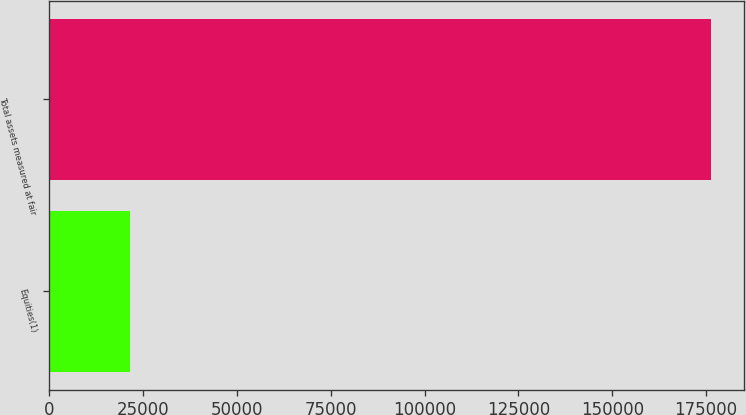Convert chart to OTSL. <chart><loc_0><loc_0><loc_500><loc_500><bar_chart><fcel>Equities(1)<fcel>Total assets measured at fair<nl><fcel>21552<fcel>176220<nl></chart> 